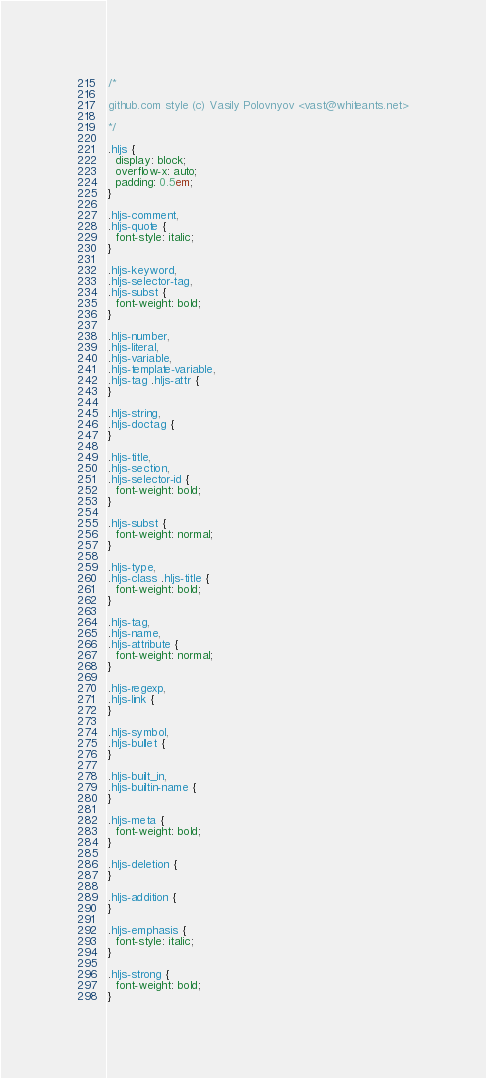<code> <loc_0><loc_0><loc_500><loc_500><_CSS_>/*

github.com style (c) Vasily Polovnyov <vast@whiteants.net>

*/

.hljs {
  display: block;
  overflow-x: auto;
  padding: 0.5em;
}

.hljs-comment,
.hljs-quote {
  font-style: italic;
}

.hljs-keyword,
.hljs-selector-tag,
.hljs-subst {
  font-weight: bold;
}

.hljs-number,
.hljs-literal,
.hljs-variable,
.hljs-template-variable,
.hljs-tag .hljs-attr {
}

.hljs-string,
.hljs-doctag {
}

.hljs-title,
.hljs-section,
.hljs-selector-id {
  font-weight: bold;
}

.hljs-subst {
  font-weight: normal;
}

.hljs-type,
.hljs-class .hljs-title {
  font-weight: bold;
}

.hljs-tag,
.hljs-name,
.hljs-attribute {
  font-weight: normal;
}

.hljs-regexp,
.hljs-link {
}

.hljs-symbol,
.hljs-bullet {
}

.hljs-built_in,
.hljs-builtin-name {
}

.hljs-meta {
  font-weight: bold;
}

.hljs-deletion {
}

.hljs-addition {
}

.hljs-emphasis {
  font-style: italic;
}

.hljs-strong {
  font-weight: bold;
}
</code> 